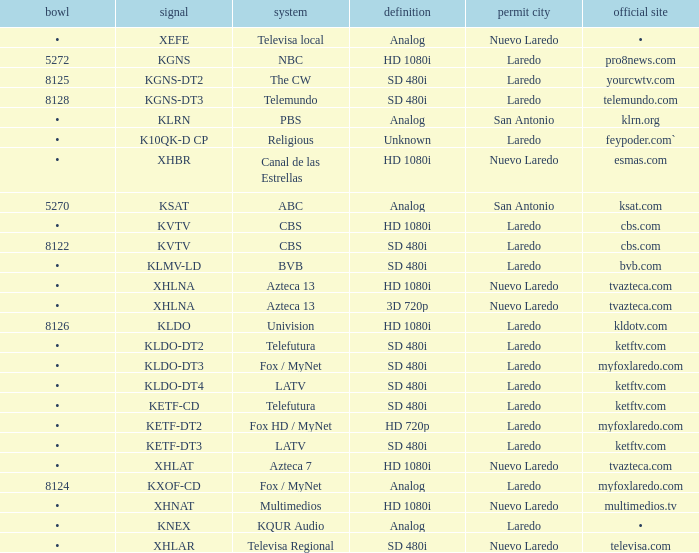Name the resolution for ketftv.com and callsign of kldo-dt2 SD 480i. 